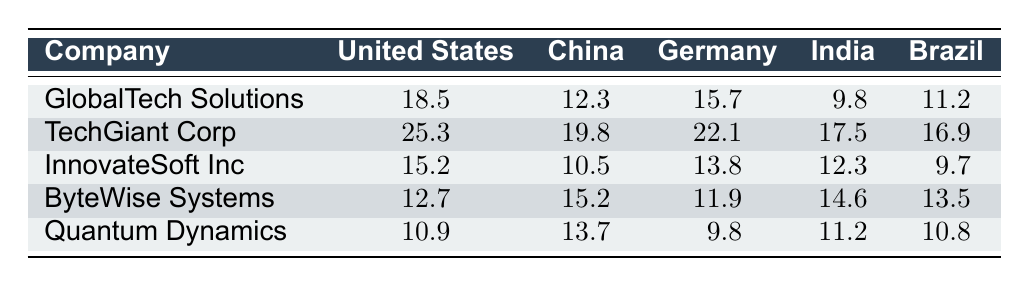What is the market share percentage of GlobalTech Solutions in the United States? According to the table, the market share percentage of GlobalTech Solutions in the United States is directly listed as 18.5.
Answer: 18.5 Which competitor has the highest market share in Germany? From the table, we can compare the values for the competitors in Germany. TechGiant Corp has the highest value at 22.1.
Answer: TechGiant Corp Is the market share of ByteWise Systems in India higher than that of Quantum Dynamics? Looking at the values in the table, ByteWise Systems has a market share of 14.6 in India, while Quantum Dynamics has 11.2. Clearly, 14.6 is greater than 11.2.
Answer: Yes What is the average market share of GlobalTech Solutions across all listed countries? To find the average market share for GlobalTech Solutions, we sum the percentages: 18.5 + 12.3 + 15.7 + 9.8 + 11.2 = 67.5. Then, divide by 5 (the number of countries), resulting in an average of 67.5 / 5 = 13.5.
Answer: 13.5 Which country has the lowest market share for InnovateSoft Inc.? The table shows InnovateSoft Inc.'s market shares: 15.2 (United States), 10.5 (China), 13.8 (Germany), 12.3 (India), and 9.7 (Brazil). The lowest value is 9.7 in Brazil.
Answer: Brazil Is TechGiant Corp's market share in China greater than that of GlobalTech Solutions? TechGiant Corp has a market share of 19.8 in China, while GlobalTech Solutions has 12.3. Since 19.8 is greater than 12.3, the answer is yes.
Answer: Yes What is the total market share of all competitors for Brazil? Adding up the market shares for Brazil: 16.9 (TechGiant Corp) + 9.7 (InnovateSoft Inc) + 13.5 (ByteWise Systems) + 10.8 (Quantum Dynamics) = 51.9.
Answer: 51.9 Which competitor has the lowest overall market share across all countries? By comparing all competitors' total market shares: TechGiant Corp (various totals), InnovateSoft Inc (various totals), ByteWise Systems (various totals), and Quantum Dynamics (various totals), Quantum Dynamics has the lowest sum in total due to lower individual market shares in most countries.
Answer: Quantum Dynamics Is the market share for GlobalTech Solutions higher in India or in China? GlobalTech Solutions has a market share of 9.8 in India and 12.3 in China. Since 12.3 is greater than 9.8, it is higher in China.
Answer: China 